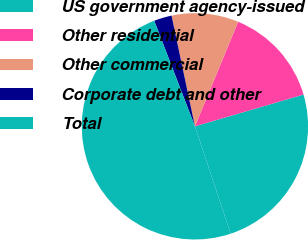Convert chart to OTSL. <chart><loc_0><loc_0><loc_500><loc_500><pie_chart><fcel>US government agency-issued<fcel>Other residential<fcel>Other commercial<fcel>Corporate debt and other<fcel>Total<nl><fcel>24.42%<fcel>14.23%<fcel>9.55%<fcel>2.54%<fcel>49.26%<nl></chart> 